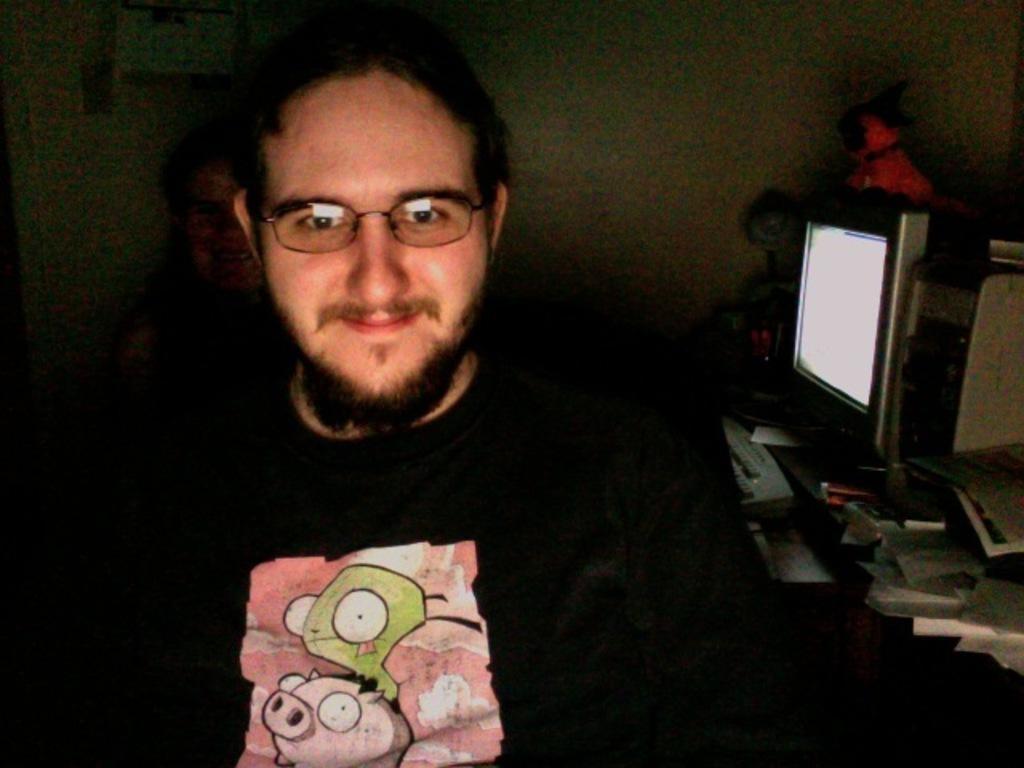Describe this image in one or two sentences. In this picture we can see a man wearing spectacles, t-shirt and he is smiling. On the right side of the picture we can see a computer, papers and objects. Background portion of the picture is blurry and a person's face is visible. 